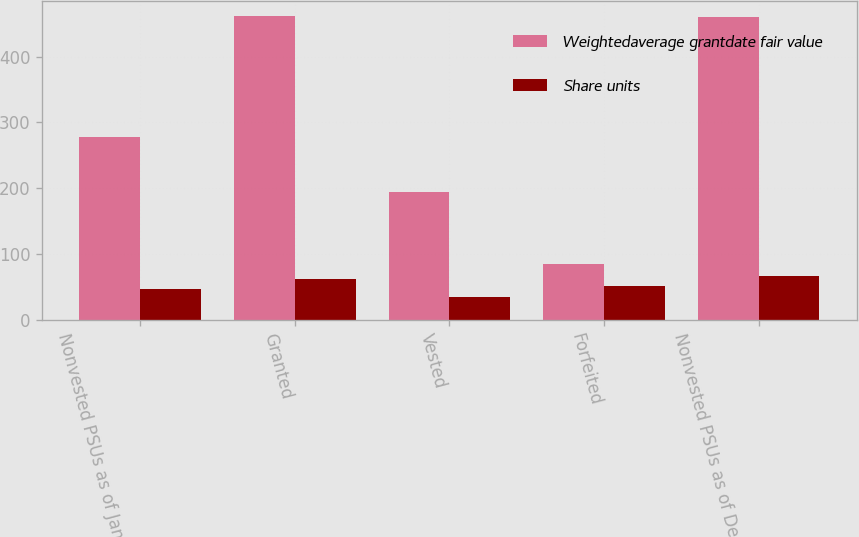Convert chart to OTSL. <chart><loc_0><loc_0><loc_500><loc_500><stacked_bar_chart><ecel><fcel>Nonvested PSUs as of January 1<fcel>Granted<fcel>Vested<fcel>Forfeited<fcel>Nonvested PSUs as of December<nl><fcel>Weightedaverage grantdate fair value<fcel>278<fcel>461<fcel>194<fcel>85<fcel>460<nl><fcel>Share units<fcel>46.82<fcel>62.22<fcel>34.35<fcel>52.31<fcel>66.5<nl></chart> 